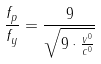<formula> <loc_0><loc_0><loc_500><loc_500>\frac { f _ { p } } { f _ { y } } = \frac { 9 } { \sqrt { 9 \cdot \frac { v ^ { 0 } } { c ^ { 0 } } } }</formula> 